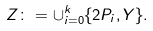Convert formula to latex. <formula><loc_0><loc_0><loc_500><loc_500>Z \colon = \cup _ { i = 0 } ^ { k } \{ 2 P _ { i } , Y \} .</formula> 